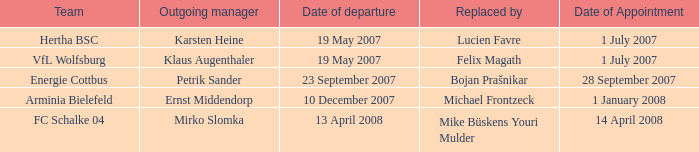When is the scheduled date for outgoing manager petrik sander's appointment? 28 September 2007. 